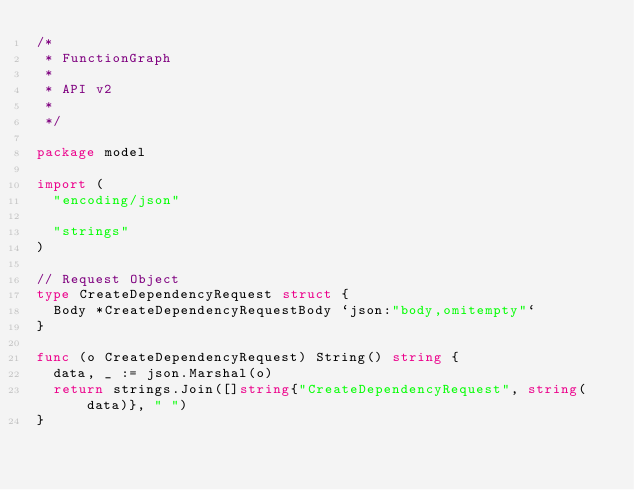<code> <loc_0><loc_0><loc_500><loc_500><_Go_>/*
 * FunctionGraph
 *
 * API v2
 *
 */

package model

import (
	"encoding/json"

	"strings"
)

// Request Object
type CreateDependencyRequest struct {
	Body *CreateDependencyRequestBody `json:"body,omitempty"`
}

func (o CreateDependencyRequest) String() string {
	data, _ := json.Marshal(o)
	return strings.Join([]string{"CreateDependencyRequest", string(data)}, " ")
}
</code> 